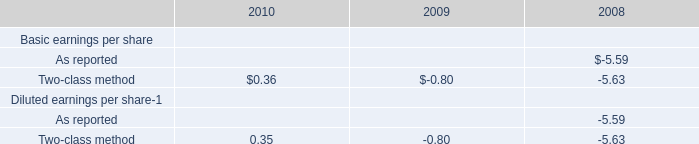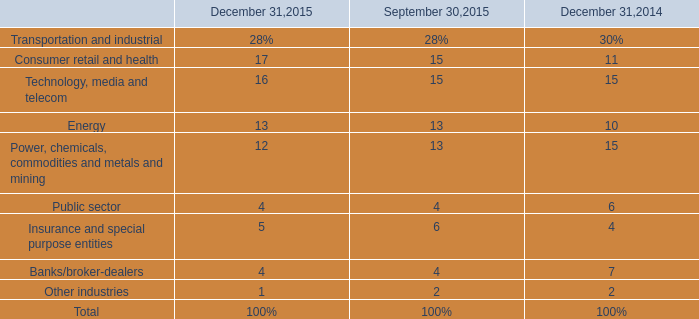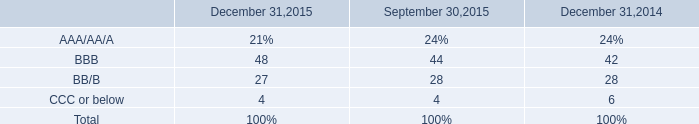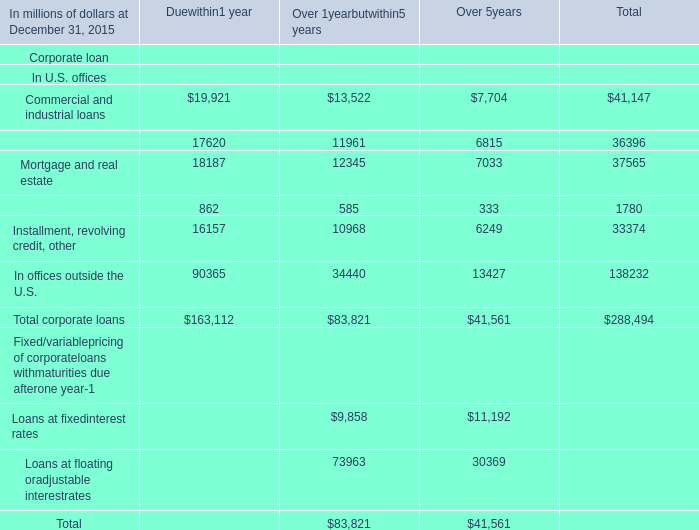What is the rate for the Other industries in the year where the rate for Technology, media and telecom on December 31 is greater than 15%? 
Computations: (1 / 100)
Answer: 0.01. 